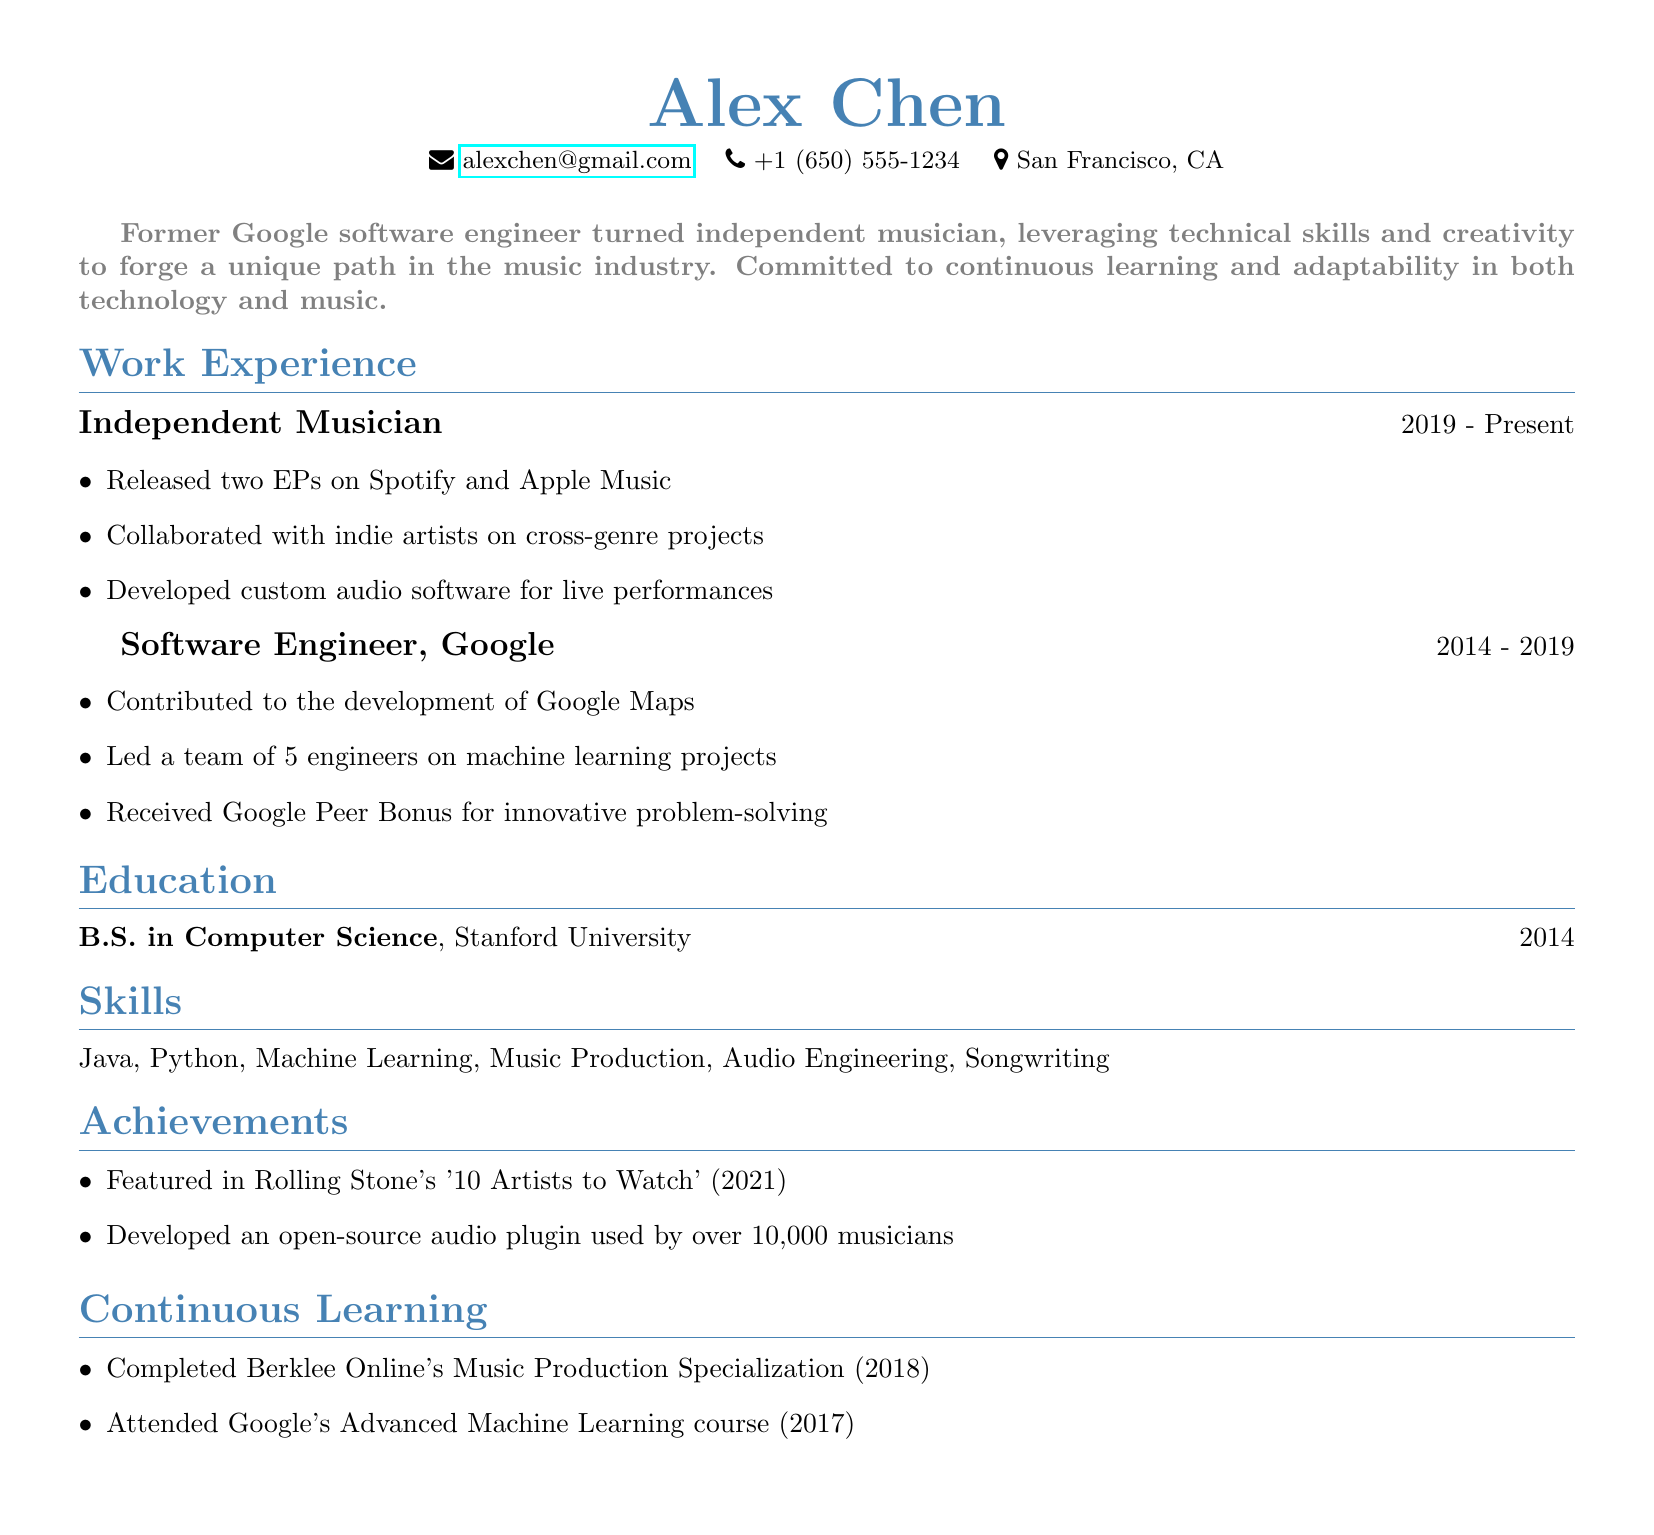what is the name of the individual? The document starts with the name of the individual, which is prominently displayed.
Answer: Alex Chen what position did Alex hold at Google? One of the work experiences listed is the title of the individual’s position at Google.
Answer: Software Engineer how many EPs has Alex released? The highlights of the independent musician's experience mention the number of EPs released.
Answer: two which university did Alex attend? The education section lists the institution where the individual earned their degree.
Answer: Stanford University what year did Alex complete their B.S. in Computer Science? The education section provides a year associated with the degree obtained.
Answer: 2014 what notable achievement is mentioned in Rolling Stone? One of the achievements highlights a feature in Rolling Stone magazine.
Answer: 10 Artists to Watch how long did Alex work at Google? The duration of time spent at Google can be calculated from the work experience section.
Answer: 5 years what is one of the skills that Alex possesses? The skills section lists the competencies that Alex has acquired.
Answer: Music Production what type of course did Alex attend at Google? The continuous learning section specifies the type of course attended.
Answer: Advanced Machine Learning 